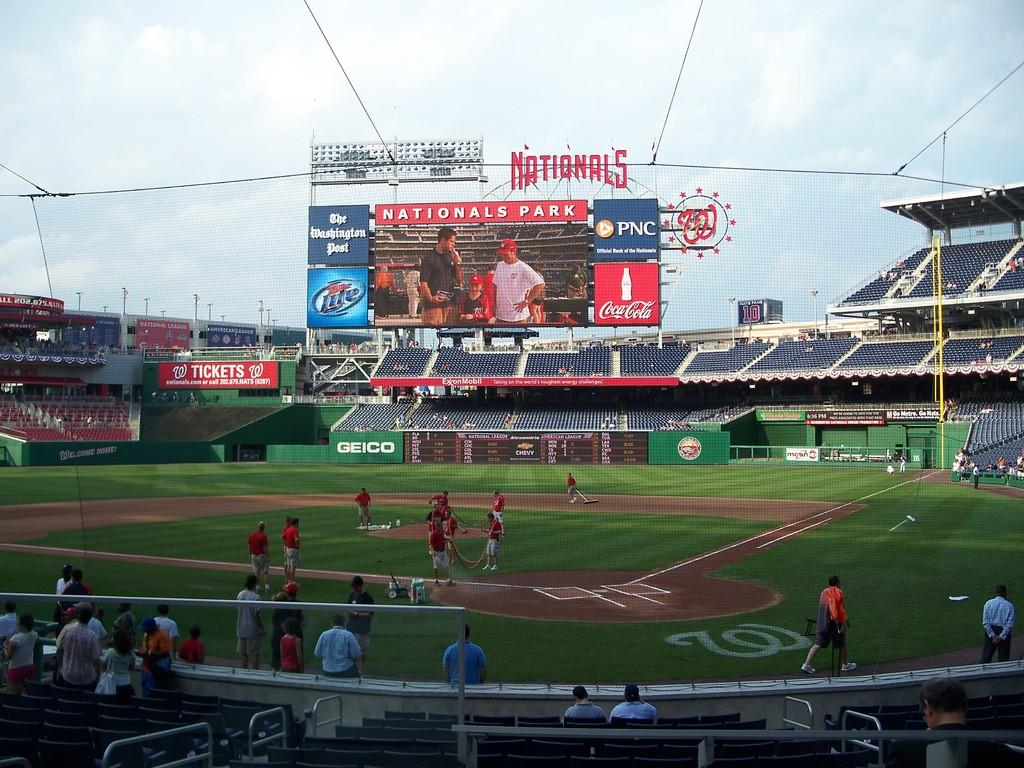Provide a one-sentence caption for the provided image. inside the washington nationals baseball park with small number of people. 